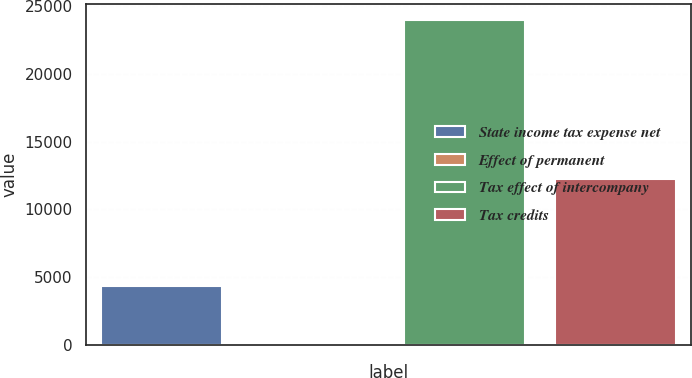Convert chart. <chart><loc_0><loc_0><loc_500><loc_500><bar_chart><fcel>State income tax expense net<fcel>Effect of permanent<fcel>Tax effect of intercompany<fcel>Tax credits<nl><fcel>4364<fcel>154<fcel>23969<fcel>12271<nl></chart> 